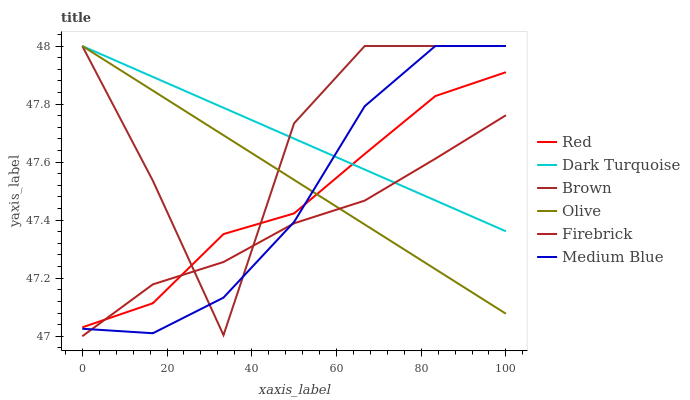Does Firebrick have the minimum area under the curve?
Answer yes or no. Yes. Does Brown have the maximum area under the curve?
Answer yes or no. Yes. Does Dark Turquoise have the minimum area under the curve?
Answer yes or no. No. Does Dark Turquoise have the maximum area under the curve?
Answer yes or no. No. Is Olive the smoothest?
Answer yes or no. Yes. Is Brown the roughest?
Answer yes or no. Yes. Is Dark Turquoise the smoothest?
Answer yes or no. No. Is Dark Turquoise the roughest?
Answer yes or no. No. Does Dark Turquoise have the lowest value?
Answer yes or no. No. Does Firebrick have the highest value?
Answer yes or no. No. 